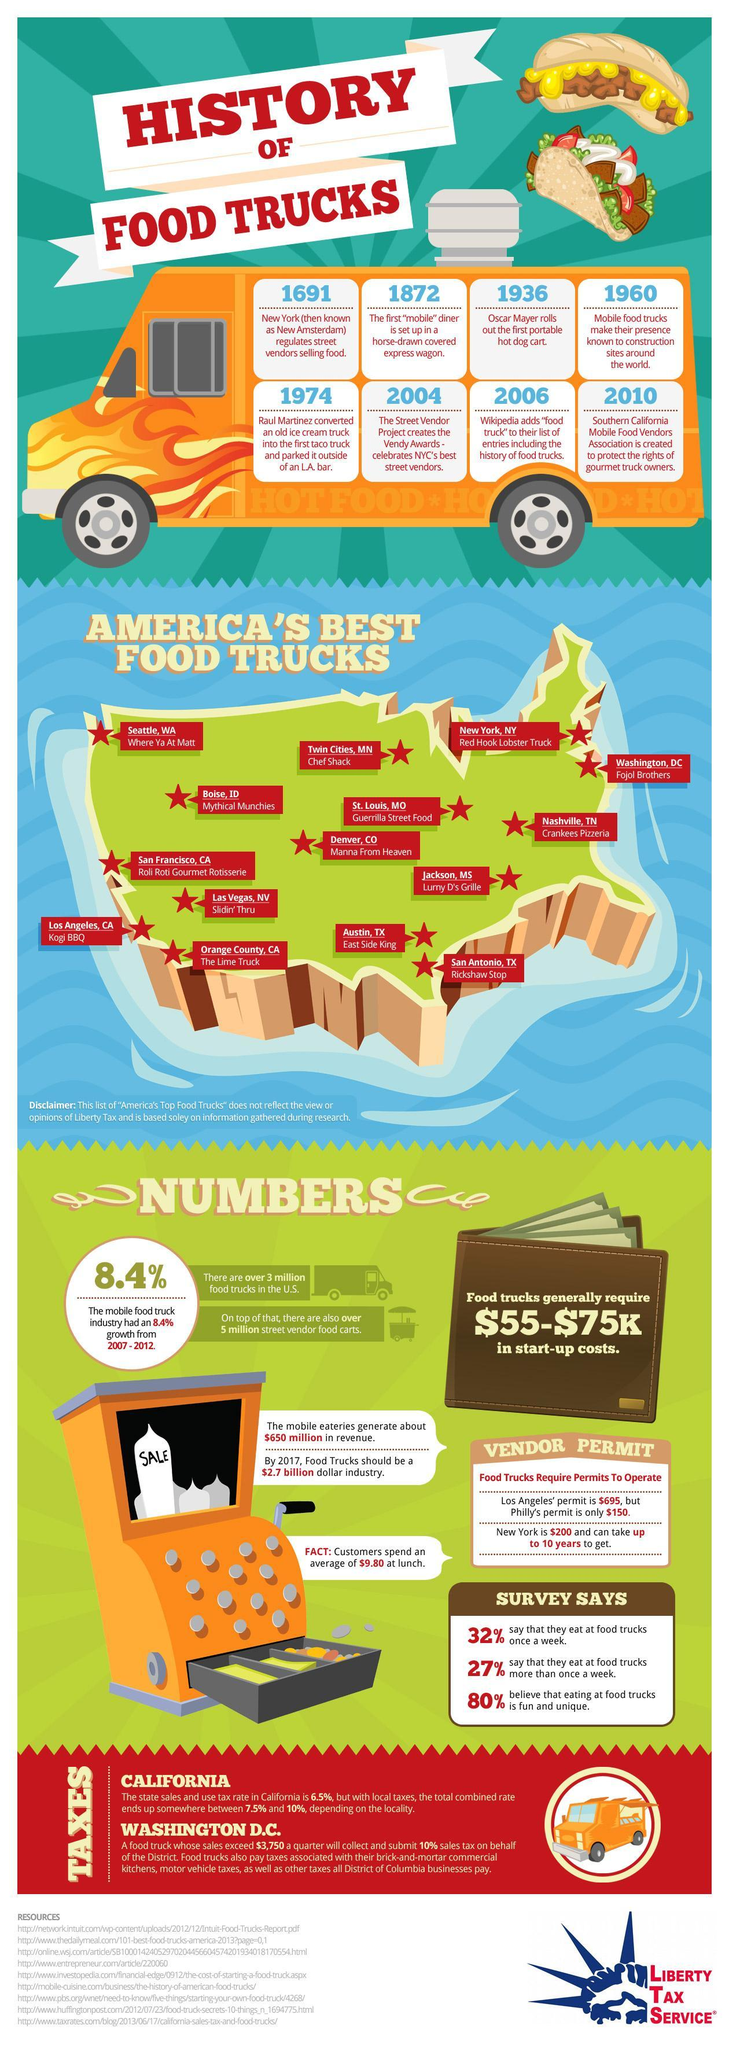Which cities in California has some the most popular food trucks?
Answer the question with a short phrase. San Francisco, Los Angeles Which city charges the highest amount to process vendor permits, Los Angeles, Philadelphia, or New York? Los Angeles Which was the first food sold using mobile carts, ice cream, tacos, or hot dog? hot dog Who was instrumental in introducing food truck in the US, Oscar Mayer, Raul Martinez, or Fojol Brothers? Raul Martinez What is the count of America's best food trucks? 15 Which year saw awards being constituted for vendors selling food on street? 2004 Which are the best food trucks in Texas? East Side King, Rickshaw Stop When was the first moving restaurant introduced? 1872 